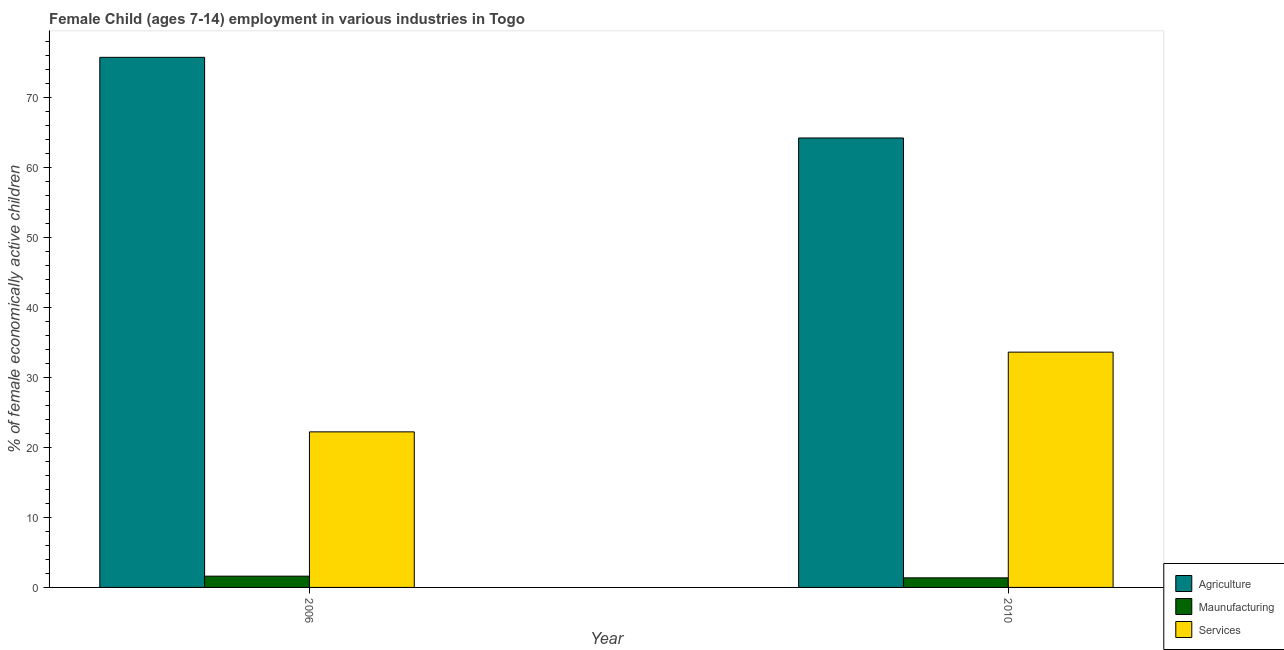Are the number of bars on each tick of the X-axis equal?
Provide a succinct answer. Yes. In how many cases, is the number of bars for a given year not equal to the number of legend labels?
Offer a terse response. 0. What is the percentage of economically active children in agriculture in 2006?
Keep it short and to the point. 75.79. Across all years, what is the maximum percentage of economically active children in manufacturing?
Provide a succinct answer. 1.61. Across all years, what is the minimum percentage of economically active children in manufacturing?
Your answer should be compact. 1.37. In which year was the percentage of economically active children in manufacturing maximum?
Keep it short and to the point. 2006. In which year was the percentage of economically active children in agriculture minimum?
Ensure brevity in your answer.  2010. What is the total percentage of economically active children in manufacturing in the graph?
Keep it short and to the point. 2.98. What is the difference between the percentage of economically active children in manufacturing in 2006 and that in 2010?
Keep it short and to the point. 0.24. What is the difference between the percentage of economically active children in manufacturing in 2010 and the percentage of economically active children in services in 2006?
Give a very brief answer. -0.24. What is the average percentage of economically active children in agriculture per year?
Your answer should be compact. 70.03. In how many years, is the percentage of economically active children in manufacturing greater than 38 %?
Offer a very short reply. 0. What is the ratio of the percentage of economically active children in services in 2006 to that in 2010?
Make the answer very short. 0.66. In how many years, is the percentage of economically active children in manufacturing greater than the average percentage of economically active children in manufacturing taken over all years?
Ensure brevity in your answer.  1. What does the 1st bar from the left in 2010 represents?
Provide a succinct answer. Agriculture. What does the 2nd bar from the right in 2010 represents?
Make the answer very short. Maunufacturing. How many bars are there?
Keep it short and to the point. 6. Are all the bars in the graph horizontal?
Your answer should be very brief. No. Are the values on the major ticks of Y-axis written in scientific E-notation?
Keep it short and to the point. No. How many legend labels are there?
Give a very brief answer. 3. What is the title of the graph?
Your answer should be compact. Female Child (ages 7-14) employment in various industries in Togo. Does "New Zealand" appear as one of the legend labels in the graph?
Make the answer very short. No. What is the label or title of the Y-axis?
Offer a very short reply. % of female economically active children. What is the % of female economically active children of Agriculture in 2006?
Ensure brevity in your answer.  75.79. What is the % of female economically active children in Maunufacturing in 2006?
Give a very brief answer. 1.61. What is the % of female economically active children in Services in 2006?
Provide a short and direct response. 22.24. What is the % of female economically active children of Agriculture in 2010?
Offer a very short reply. 64.26. What is the % of female economically active children in Maunufacturing in 2010?
Keep it short and to the point. 1.37. What is the % of female economically active children of Services in 2010?
Your response must be concise. 33.64. Across all years, what is the maximum % of female economically active children in Agriculture?
Keep it short and to the point. 75.79. Across all years, what is the maximum % of female economically active children of Maunufacturing?
Your answer should be compact. 1.61. Across all years, what is the maximum % of female economically active children in Services?
Your answer should be very brief. 33.64. Across all years, what is the minimum % of female economically active children in Agriculture?
Keep it short and to the point. 64.26. Across all years, what is the minimum % of female economically active children of Maunufacturing?
Keep it short and to the point. 1.37. Across all years, what is the minimum % of female economically active children in Services?
Make the answer very short. 22.24. What is the total % of female economically active children of Agriculture in the graph?
Provide a short and direct response. 140.05. What is the total % of female economically active children of Maunufacturing in the graph?
Offer a very short reply. 2.98. What is the total % of female economically active children of Services in the graph?
Provide a short and direct response. 55.88. What is the difference between the % of female economically active children in Agriculture in 2006 and that in 2010?
Offer a terse response. 11.53. What is the difference between the % of female economically active children in Maunufacturing in 2006 and that in 2010?
Make the answer very short. 0.24. What is the difference between the % of female economically active children in Agriculture in 2006 and the % of female economically active children in Maunufacturing in 2010?
Offer a terse response. 74.42. What is the difference between the % of female economically active children of Agriculture in 2006 and the % of female economically active children of Services in 2010?
Provide a short and direct response. 42.15. What is the difference between the % of female economically active children in Maunufacturing in 2006 and the % of female economically active children in Services in 2010?
Give a very brief answer. -32.03. What is the average % of female economically active children in Agriculture per year?
Your answer should be very brief. 70.03. What is the average % of female economically active children of Maunufacturing per year?
Make the answer very short. 1.49. What is the average % of female economically active children of Services per year?
Your answer should be compact. 27.94. In the year 2006, what is the difference between the % of female economically active children of Agriculture and % of female economically active children of Maunufacturing?
Ensure brevity in your answer.  74.18. In the year 2006, what is the difference between the % of female economically active children in Agriculture and % of female economically active children in Services?
Provide a short and direct response. 53.55. In the year 2006, what is the difference between the % of female economically active children in Maunufacturing and % of female economically active children in Services?
Give a very brief answer. -20.63. In the year 2010, what is the difference between the % of female economically active children in Agriculture and % of female economically active children in Maunufacturing?
Provide a succinct answer. 62.89. In the year 2010, what is the difference between the % of female economically active children of Agriculture and % of female economically active children of Services?
Give a very brief answer. 30.62. In the year 2010, what is the difference between the % of female economically active children in Maunufacturing and % of female economically active children in Services?
Provide a short and direct response. -32.27. What is the ratio of the % of female economically active children of Agriculture in 2006 to that in 2010?
Offer a terse response. 1.18. What is the ratio of the % of female economically active children of Maunufacturing in 2006 to that in 2010?
Provide a short and direct response. 1.18. What is the ratio of the % of female economically active children in Services in 2006 to that in 2010?
Provide a succinct answer. 0.66. What is the difference between the highest and the second highest % of female economically active children in Agriculture?
Your answer should be very brief. 11.53. What is the difference between the highest and the second highest % of female economically active children of Maunufacturing?
Your answer should be very brief. 0.24. What is the difference between the highest and the second highest % of female economically active children in Services?
Offer a very short reply. 11.4. What is the difference between the highest and the lowest % of female economically active children of Agriculture?
Your answer should be compact. 11.53. What is the difference between the highest and the lowest % of female economically active children in Maunufacturing?
Make the answer very short. 0.24. 